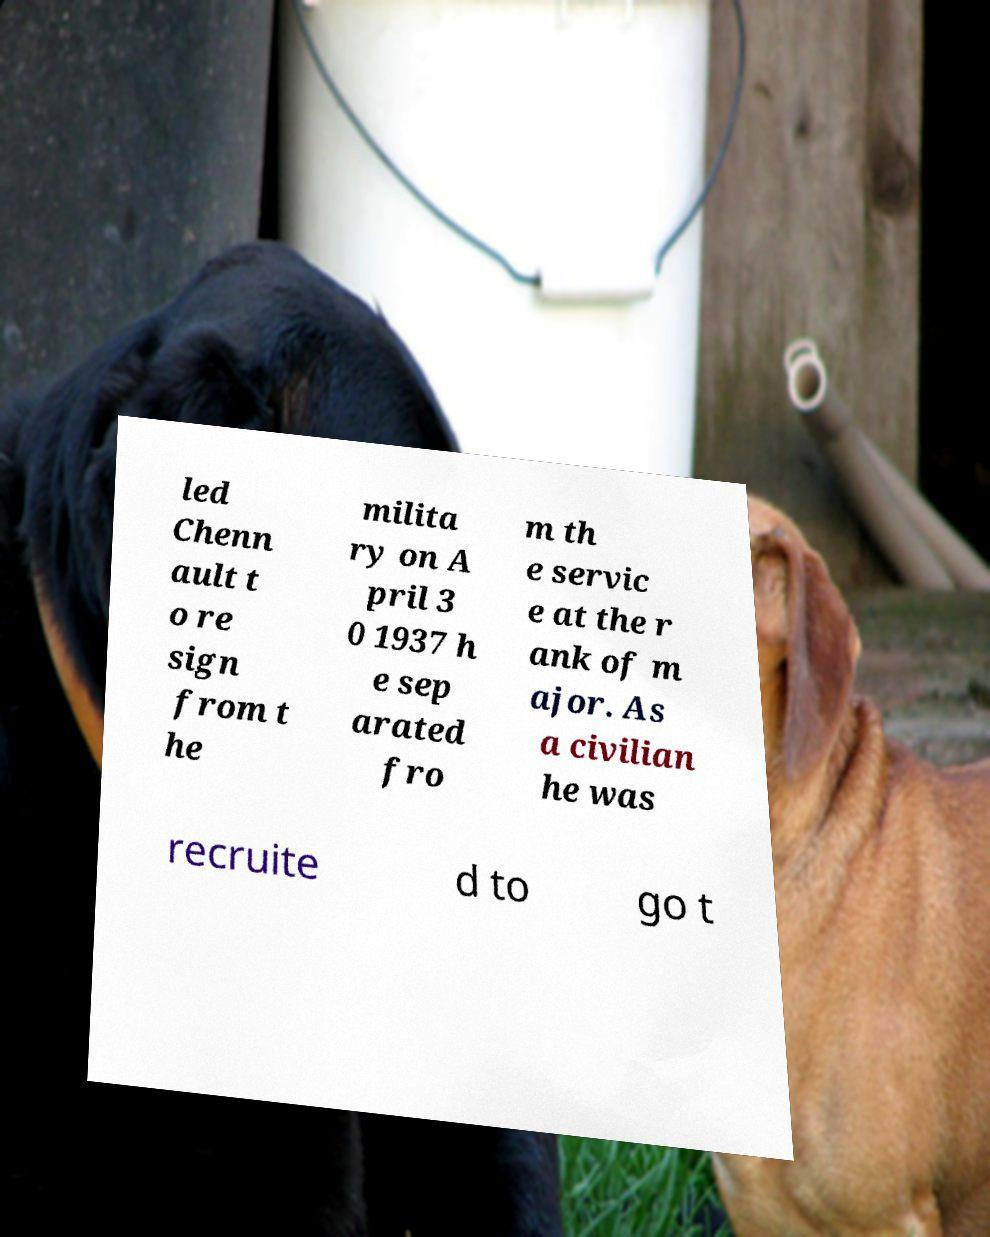Could you extract and type out the text from this image? led Chenn ault t o re sign from t he milita ry on A pril 3 0 1937 h e sep arated fro m th e servic e at the r ank of m ajor. As a civilian he was recruite d to go t 